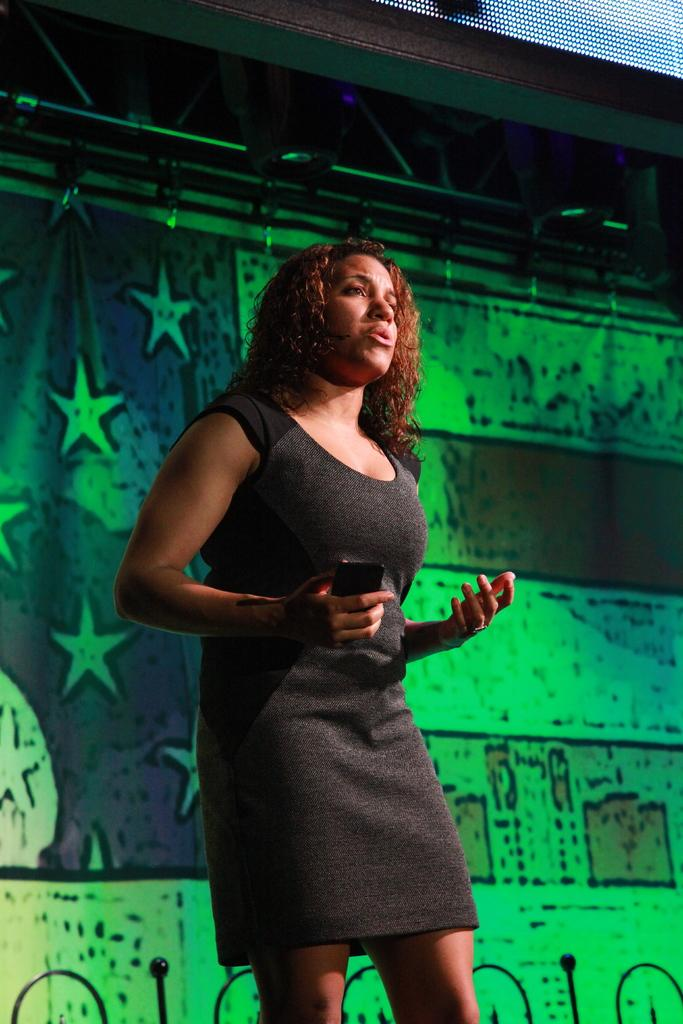What is the primary subject of the image? There is a woman in the image. What is the woman doing in the image? The woman is standing and talking. What is the woman holding in the image? The woman is holding a device. What can be seen in the background of the image? There is a hoarding in the background of the image. What is visible at the top of the image? There is a road visible at the top of the image. What type of illumination is present in the image? There are lights present in the image. How many pins are attached to the yak in the image? There is no yak or pins present in the image. What type of base is supporting the woman in the image? The woman is standing on her own, so there is no base supporting her in the image. 